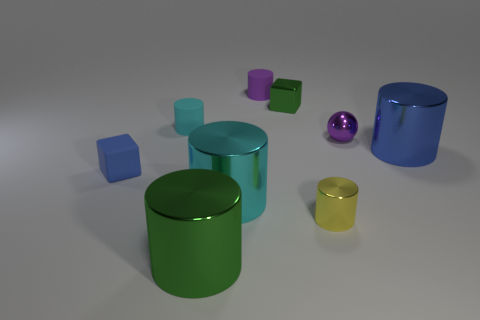Subtract all brown balls. How many cyan cylinders are left? 2 Subtract all cyan cylinders. How many cylinders are left? 4 Subtract all blue cylinders. How many cylinders are left? 5 Subtract all cyan cylinders. Subtract all brown spheres. How many cylinders are left? 4 Subtract all cylinders. How many objects are left? 3 Subtract all big green metallic cylinders. Subtract all brown blocks. How many objects are left? 8 Add 2 big metal cylinders. How many big metal cylinders are left? 5 Add 2 metallic cylinders. How many metallic cylinders exist? 6 Subtract 0 blue spheres. How many objects are left? 9 